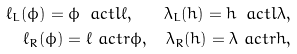<formula> <loc_0><loc_0><loc_500><loc_500>\ell _ { L } ( \phi ) = \phi \ a c t l \ell , \quad \lambda _ { L } ( h ) = h \ a c t l \lambda , \\ \ell _ { R } ( \phi ) = \ell \ a c t r \phi , \quad \lambda _ { R } ( h ) = \lambda \ a c t r h ,</formula> 